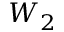<formula> <loc_0><loc_0><loc_500><loc_500>W _ { 2 }</formula> 